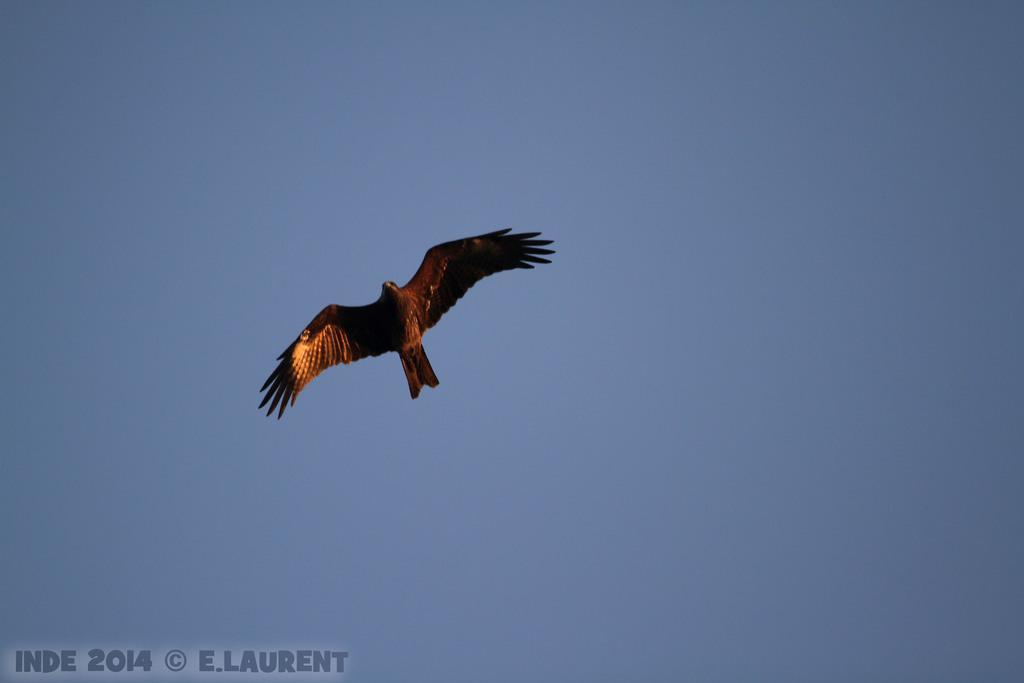Could you give a brief overview of what you see in this image? On the bottom left, there is a watermark. On the left side, there is a bird flying in the air. In the background, there is the blue sky. 